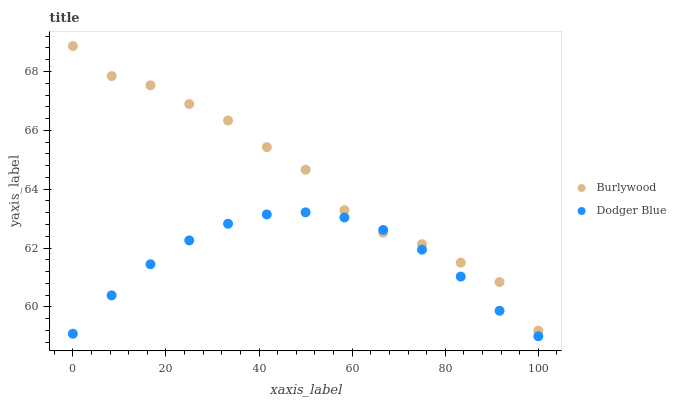Does Dodger Blue have the minimum area under the curve?
Answer yes or no. Yes. Does Burlywood have the maximum area under the curve?
Answer yes or no. Yes. Does Dodger Blue have the maximum area under the curve?
Answer yes or no. No. Is Dodger Blue the smoothest?
Answer yes or no. Yes. Is Burlywood the roughest?
Answer yes or no. Yes. Is Dodger Blue the roughest?
Answer yes or no. No. Does Dodger Blue have the lowest value?
Answer yes or no. Yes. Does Burlywood have the highest value?
Answer yes or no. Yes. Does Dodger Blue have the highest value?
Answer yes or no. No. Does Burlywood intersect Dodger Blue?
Answer yes or no. Yes. Is Burlywood less than Dodger Blue?
Answer yes or no. No. Is Burlywood greater than Dodger Blue?
Answer yes or no. No. 